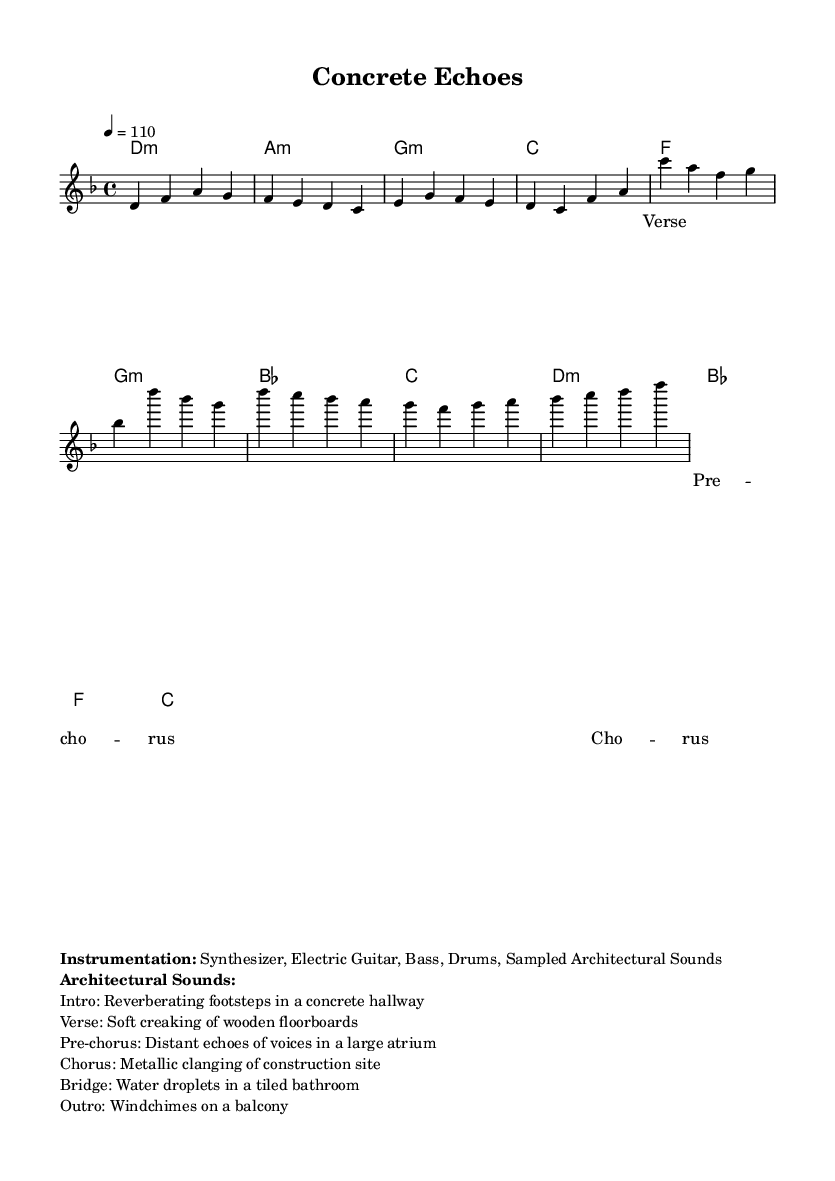What is the key signature of the music? The key signature indicated is D minor, which contains one flat (B flat). This can be determined from the key signature shown at the beginning of the sheet music.
Answer: D minor What is the time signature of the piece? The time signature provided in the music is 4/4, meaning there are four beats in each measure and the quarter note gets one beat. This can be found in the notation near the top of the score.
Answer: 4/4 What is the tempo marking of the song? The tempo marking in the score indicates a tempo of 110 beats per minute, which informs the performers how fast to play the music. This is given in the tempo indicated in the global settings.
Answer: 110 What type of sounds are used in the intro? The intro features reverberating footsteps in a concrete hallway, which is specified in the instrumentation section under architectural sounds. This sound is meant to evoke an emotional response related to the environment.
Answer: Reverberating footsteps Which instruments are included in the instrumentation? The instrumentation includes a synthesizer, electric guitar, bass, drums, and sampled architectural sounds. This information is laid out prominently in the markup section at the end of the score.
Answer: Synthesizer, Electric Guitar, Bass, Drums, Sampled Architectural Sounds What architectural sound is used in the bridge section? The bridge section incorporates the sound of water droplets in a tiled bathroom, as mentioned in the architectural sounds list provided in the markup. This distinct sound contrasts with the others to create varying emotional landscapes in the music.
Answer: Water droplets in a tiled bathroom 